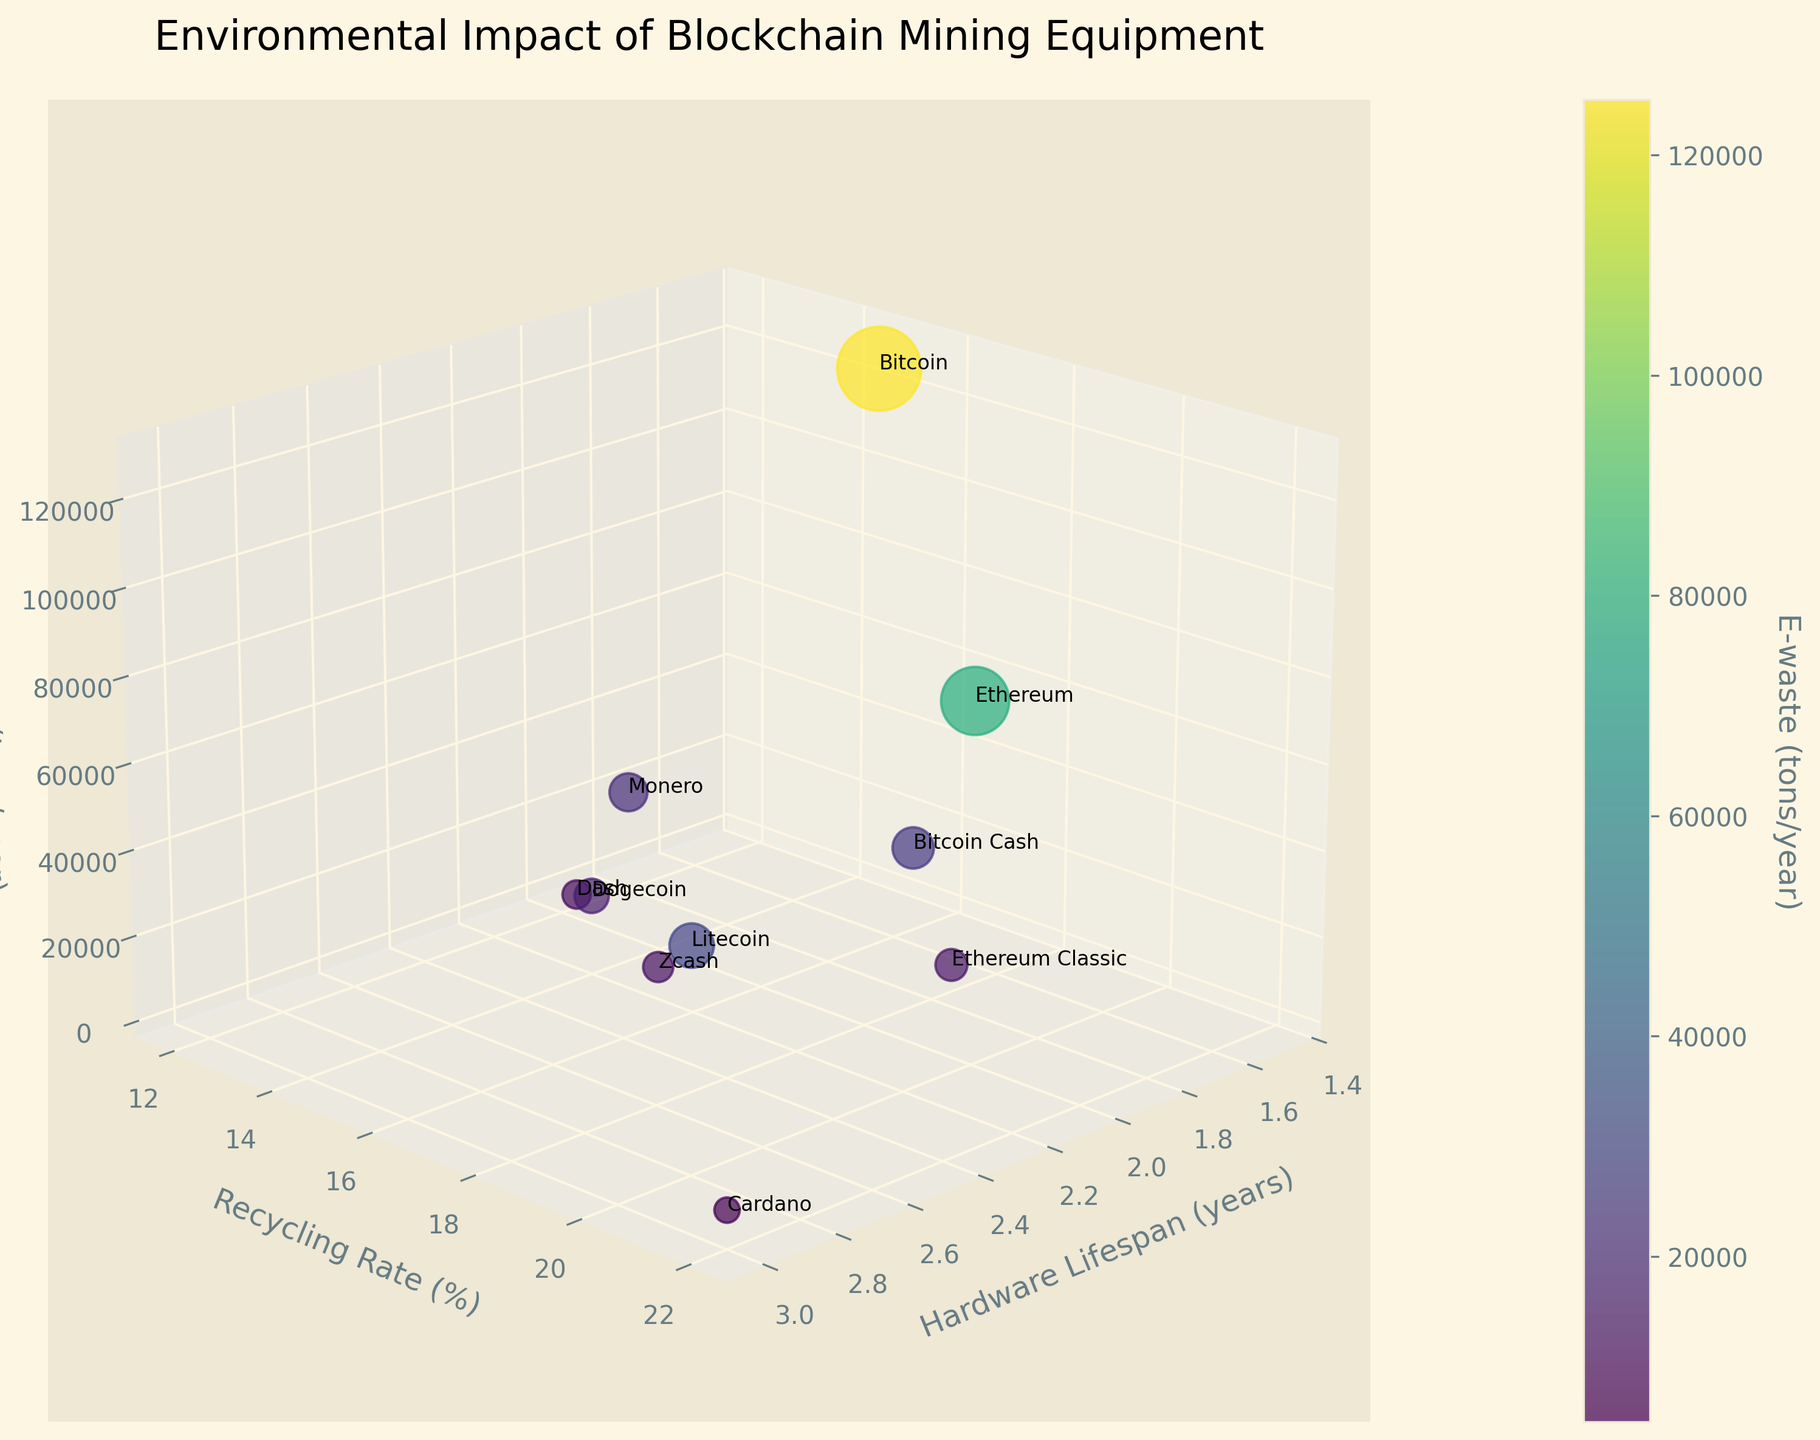What's the title of the plot? The title is often found at the top of the plot and summarizes the main subject of the visualization.
Answer: Environmental Impact of Blockchain Mining Equipment What does the colorbar represent? The colorbar typically provides a reference to understand the color gradient in the plot; in this case, it indicates the amount of e-waste (tons/year).
Answer: E-waste (tons/year) Which algorithm generates the most e-waste annually? The bubble representing Bitcoin is positioned the highest on the z-axis, which indicates it generates the most e-waste.
Answer: Bitcoin Which algorithm has the longest hardware lifespan? The x-axis represents hardware lifespan, and Cardano is positioned furthest to the right, indicating it has the longest lifespan at 3 years.
Answer: Cardano What recyclability rate does Ethereum have? Ethereum's label can be found on the plot, and it's positioned with a recycling rate, which is on the y-axis, of 20%.
Answer: 20% Compare the e-waste generation of Litecoin and Zcash. Which algorithm generates more? By examining the height on the z-axis, Litecoin's bubble is higher up than Zcash's, indicating it generates more e-waste annually.
Answer: Litecoin Which algorithm has a better recycling rate, Bitcoin Cash or Monero? Both Bitcoin Cash and Monero can be identified by their labels on the plot. Bitcoin Cash has a recycling rate of 17% while Monero has 12%, observed on the y-axis.
Answer: Bitcoin Cash What is the sum of the recycling rates for Ethereum, Litecoin, and Dash? Identify the recycling rates: Ethereum (20%), Litecoin (18%), and Dash (13%). Then, sum these values: 20 + 18 + 13 = 51%.
Answer: 51% Which algorithm has the closest balance between hardware lifespan and recycling rate? An algorithm like Cardano, with a hardware lifespan of 3 years and a recycling rate of 22%, appears to have both metrics relatively high and balanced compared to others.
Answer: Cardano Is there a correlation between hardware lifespan and e-waste for the algorithms shown? Observing the plot, algorithms with shorter hardware lifespans tend to result in higher e-waste generation, indicating a negative correlation.
Answer: Negative correlation 